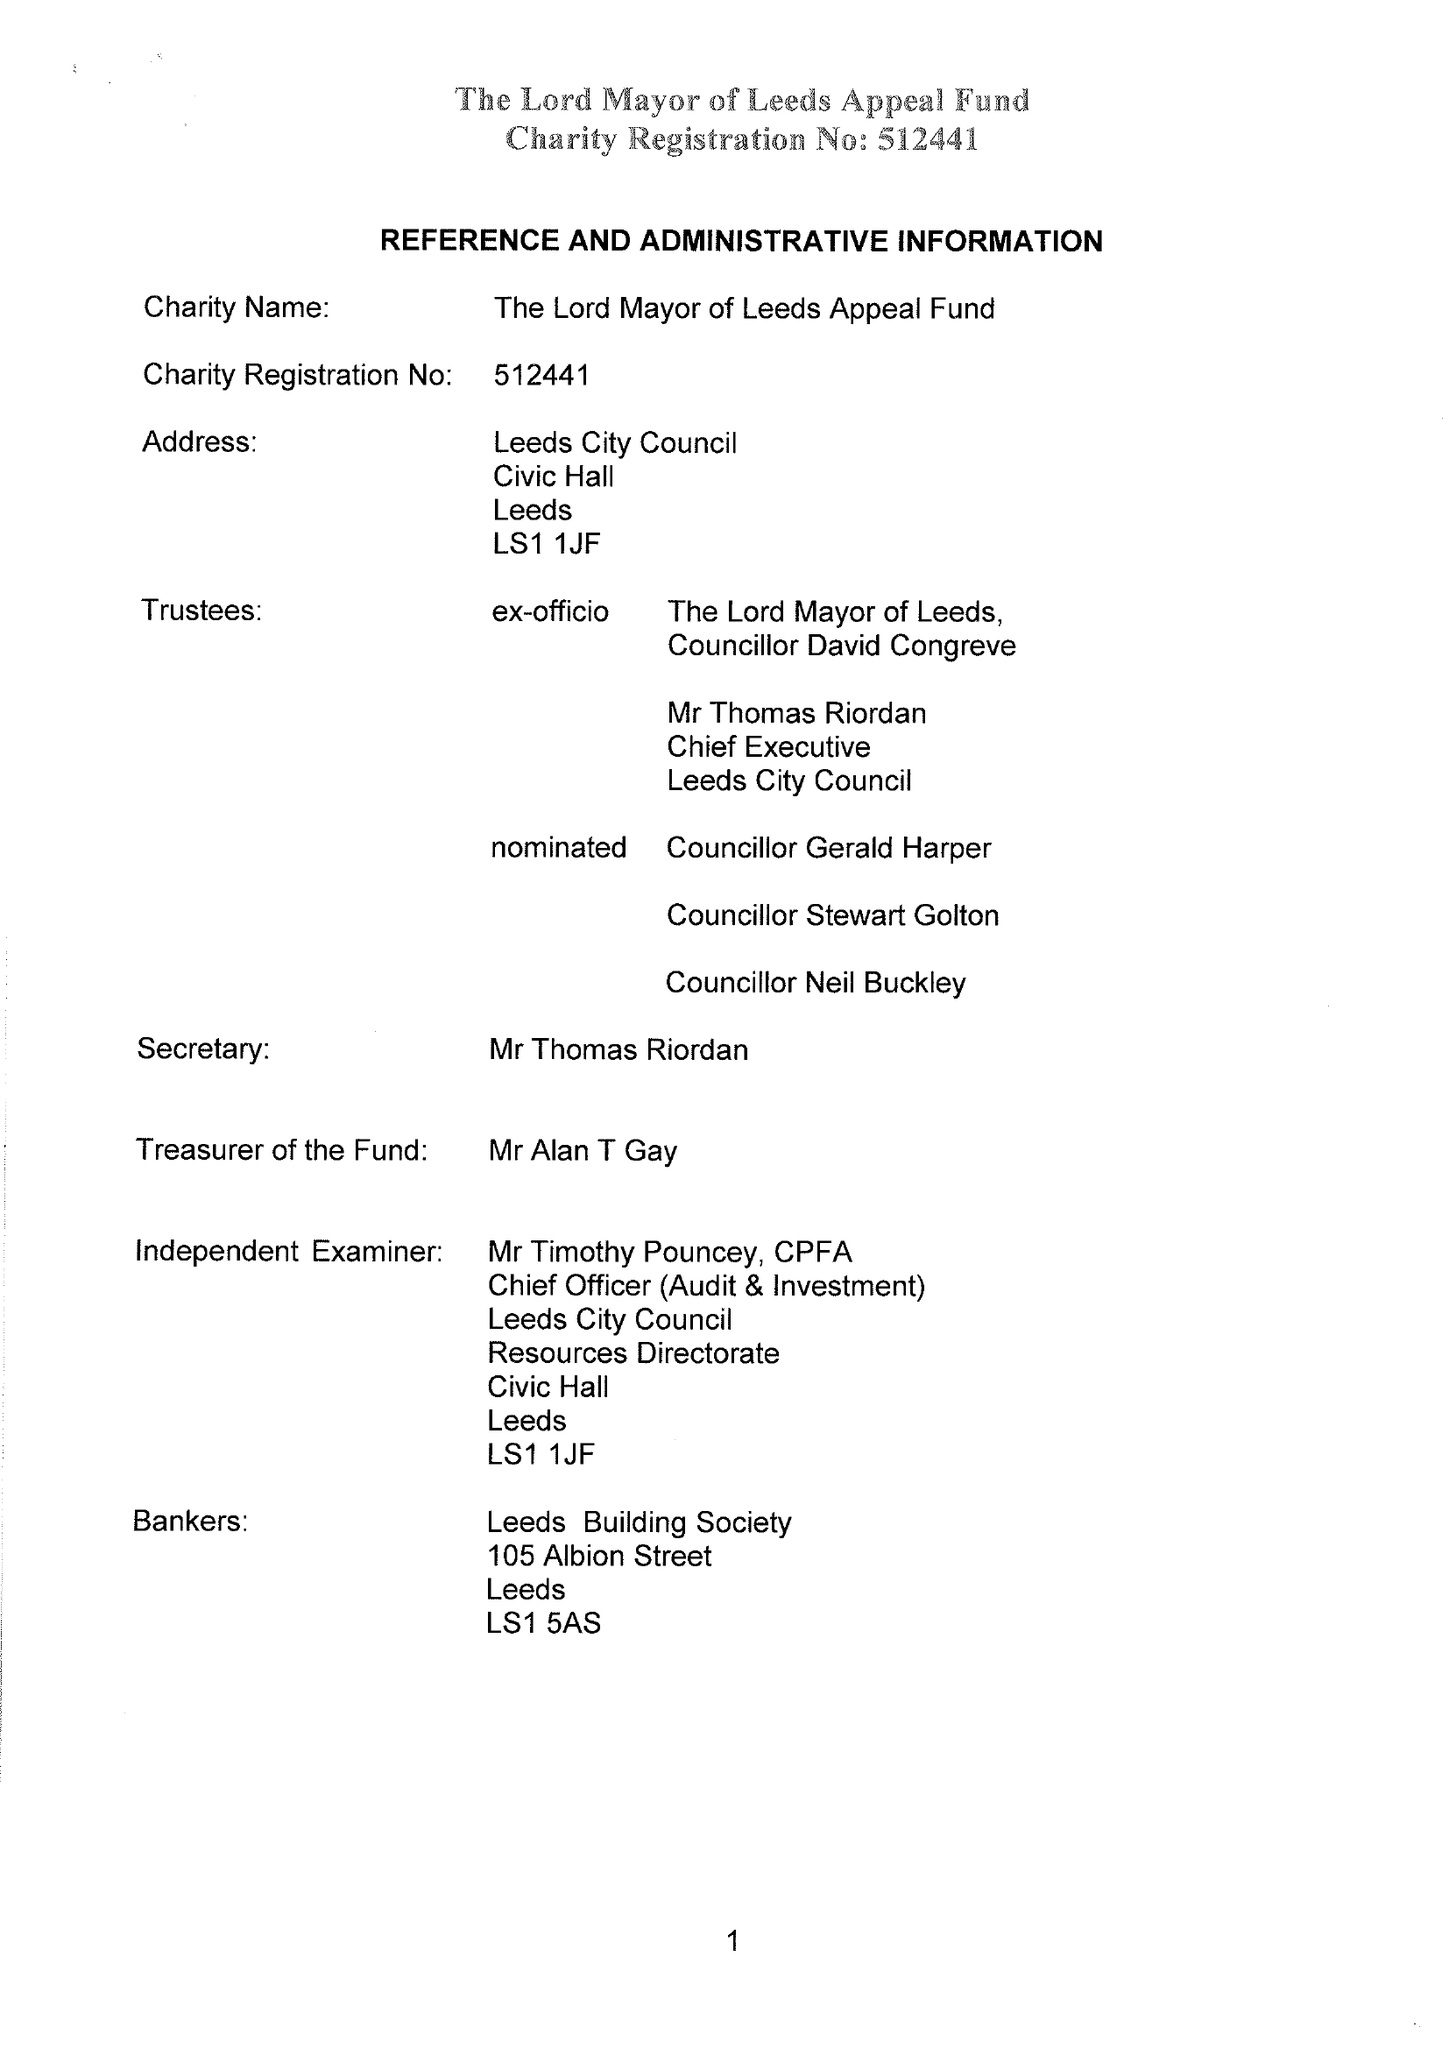What is the value for the spending_annually_in_british_pounds?
Answer the question using a single word or phrase. 18178.00 